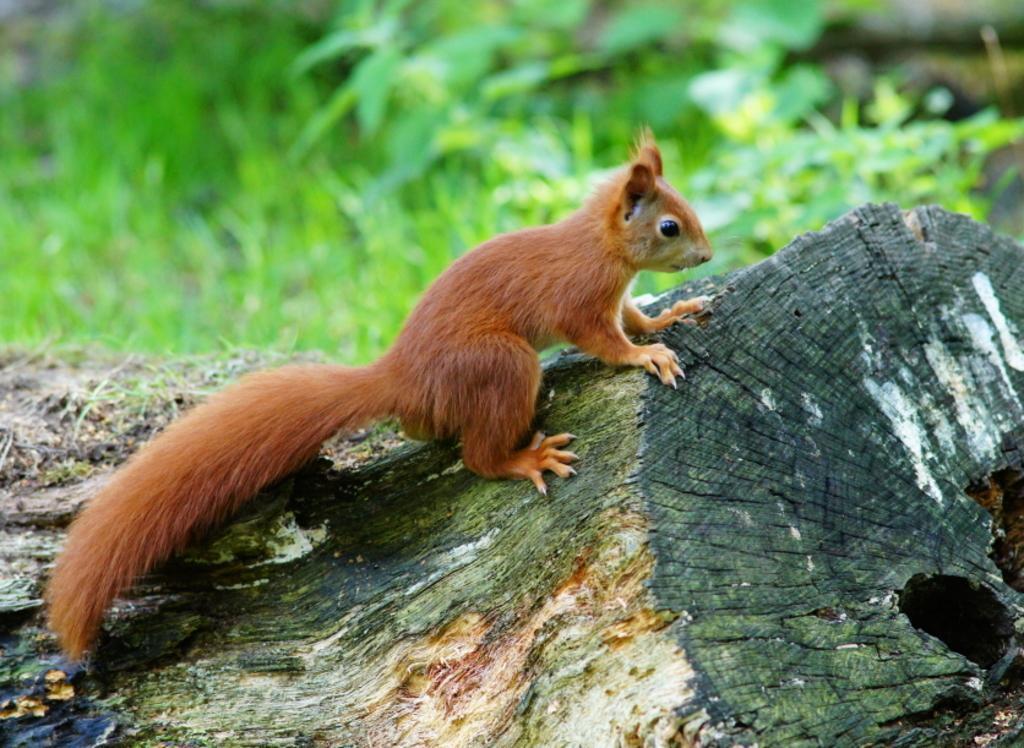Please provide a concise description of this image. This picture is clicked outside. In the center we can see an animal on a wooden object. In the background we can see the green grass and some other objects. 